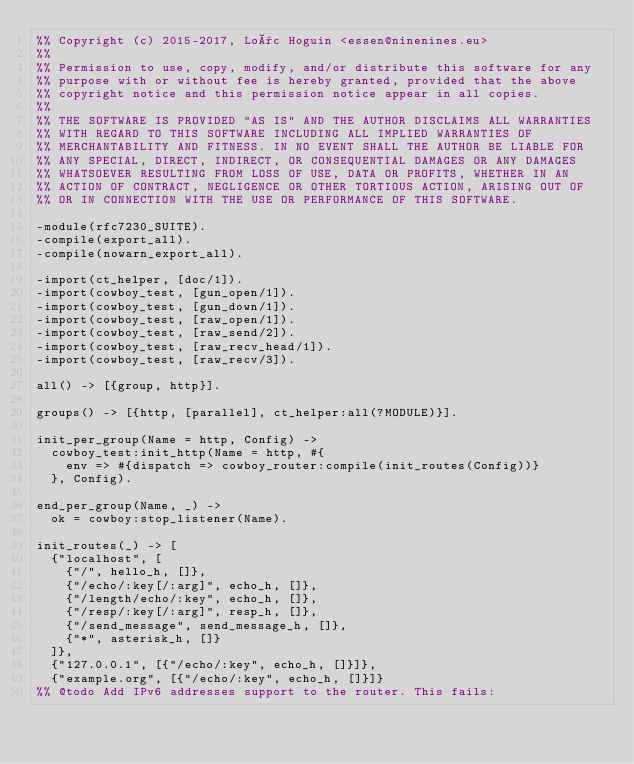<code> <loc_0><loc_0><loc_500><loc_500><_Erlang_>%% Copyright (c) 2015-2017, Loïc Hoguin <essen@ninenines.eu>
%%
%% Permission to use, copy, modify, and/or distribute this software for any
%% purpose with or without fee is hereby granted, provided that the above
%% copyright notice and this permission notice appear in all copies.
%%
%% THE SOFTWARE IS PROVIDED "AS IS" AND THE AUTHOR DISCLAIMS ALL WARRANTIES
%% WITH REGARD TO THIS SOFTWARE INCLUDING ALL IMPLIED WARRANTIES OF
%% MERCHANTABILITY AND FITNESS. IN NO EVENT SHALL THE AUTHOR BE LIABLE FOR
%% ANY SPECIAL, DIRECT, INDIRECT, OR CONSEQUENTIAL DAMAGES OR ANY DAMAGES
%% WHATSOEVER RESULTING FROM LOSS OF USE, DATA OR PROFITS, WHETHER IN AN
%% ACTION OF CONTRACT, NEGLIGENCE OR OTHER TORTIOUS ACTION, ARISING OUT OF
%% OR IN CONNECTION WITH THE USE OR PERFORMANCE OF THIS SOFTWARE.

-module(rfc7230_SUITE).
-compile(export_all).
-compile(nowarn_export_all).

-import(ct_helper, [doc/1]).
-import(cowboy_test, [gun_open/1]).
-import(cowboy_test, [gun_down/1]).
-import(cowboy_test, [raw_open/1]).
-import(cowboy_test, [raw_send/2]).
-import(cowboy_test, [raw_recv_head/1]).
-import(cowboy_test, [raw_recv/3]).

all() -> [{group, http}].

groups() -> [{http, [parallel], ct_helper:all(?MODULE)}].

init_per_group(Name = http, Config) ->
	cowboy_test:init_http(Name = http, #{
		env => #{dispatch => cowboy_router:compile(init_routes(Config))}
	}, Config).

end_per_group(Name, _) ->
	ok = cowboy:stop_listener(Name).

init_routes(_) -> [
	{"localhost", [
		{"/", hello_h, []},
		{"/echo/:key[/:arg]", echo_h, []},
		{"/length/echo/:key", echo_h, []},
		{"/resp/:key[/:arg]", resp_h, []},
		{"/send_message", send_message_h, []},
		{"*", asterisk_h, []}
	]},
	{"127.0.0.1", [{"/echo/:key", echo_h, []}]},
	{"example.org", [{"/echo/:key", echo_h, []}]}
%% @todo Add IPv6 addresses support to the router. This fails:</code> 